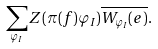<formula> <loc_0><loc_0><loc_500><loc_500>\sum _ { \varphi _ { I } } Z ( \pi ( f ) \varphi _ { I } ) \overline { W _ { \varphi _ { I } } ( e ) } .</formula> 